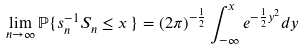<formula> <loc_0><loc_0><loc_500><loc_500>\lim _ { n \to \infty } \mathbb { P } \{ s _ { n } ^ { - 1 } S _ { n } \leq x \, \} = ( 2 \pi ) ^ { - \frac { 1 } { 2 } } \int _ { - \infty } ^ { x } e ^ { - \frac { 1 } { 2 } y ^ { 2 } } d y</formula> 